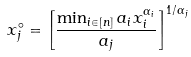<formula> <loc_0><loc_0><loc_500><loc_500>x ^ { \circ } _ { j } = \left [ \frac { \min _ { i \in [ n ] } a _ { i } x _ { i } ^ { \alpha _ { i } } } { a _ { j } } \right ] ^ { 1 / \alpha _ { j } }</formula> 